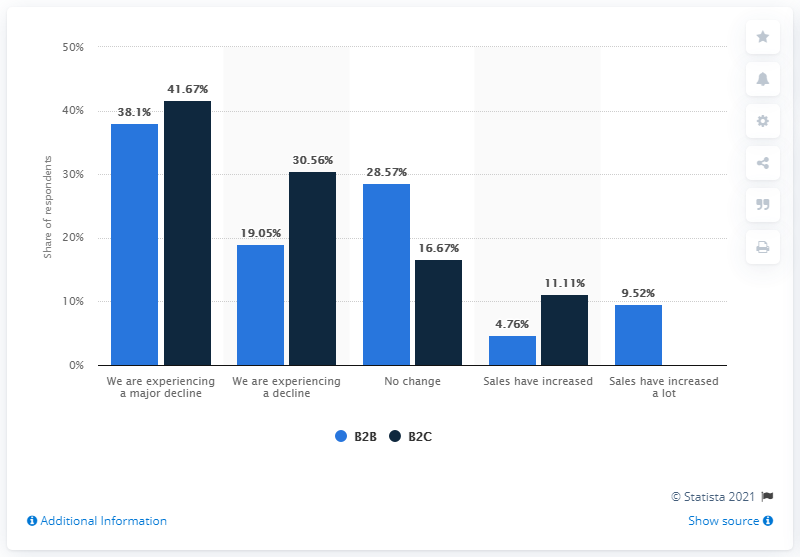Give some essential details in this illustration. According to a recent study, 38.1% of B2B companies experienced a decline in sales due to the COVID-19 pandemic. 